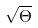<formula> <loc_0><loc_0><loc_500><loc_500>\sqrt { \Theta }</formula> 